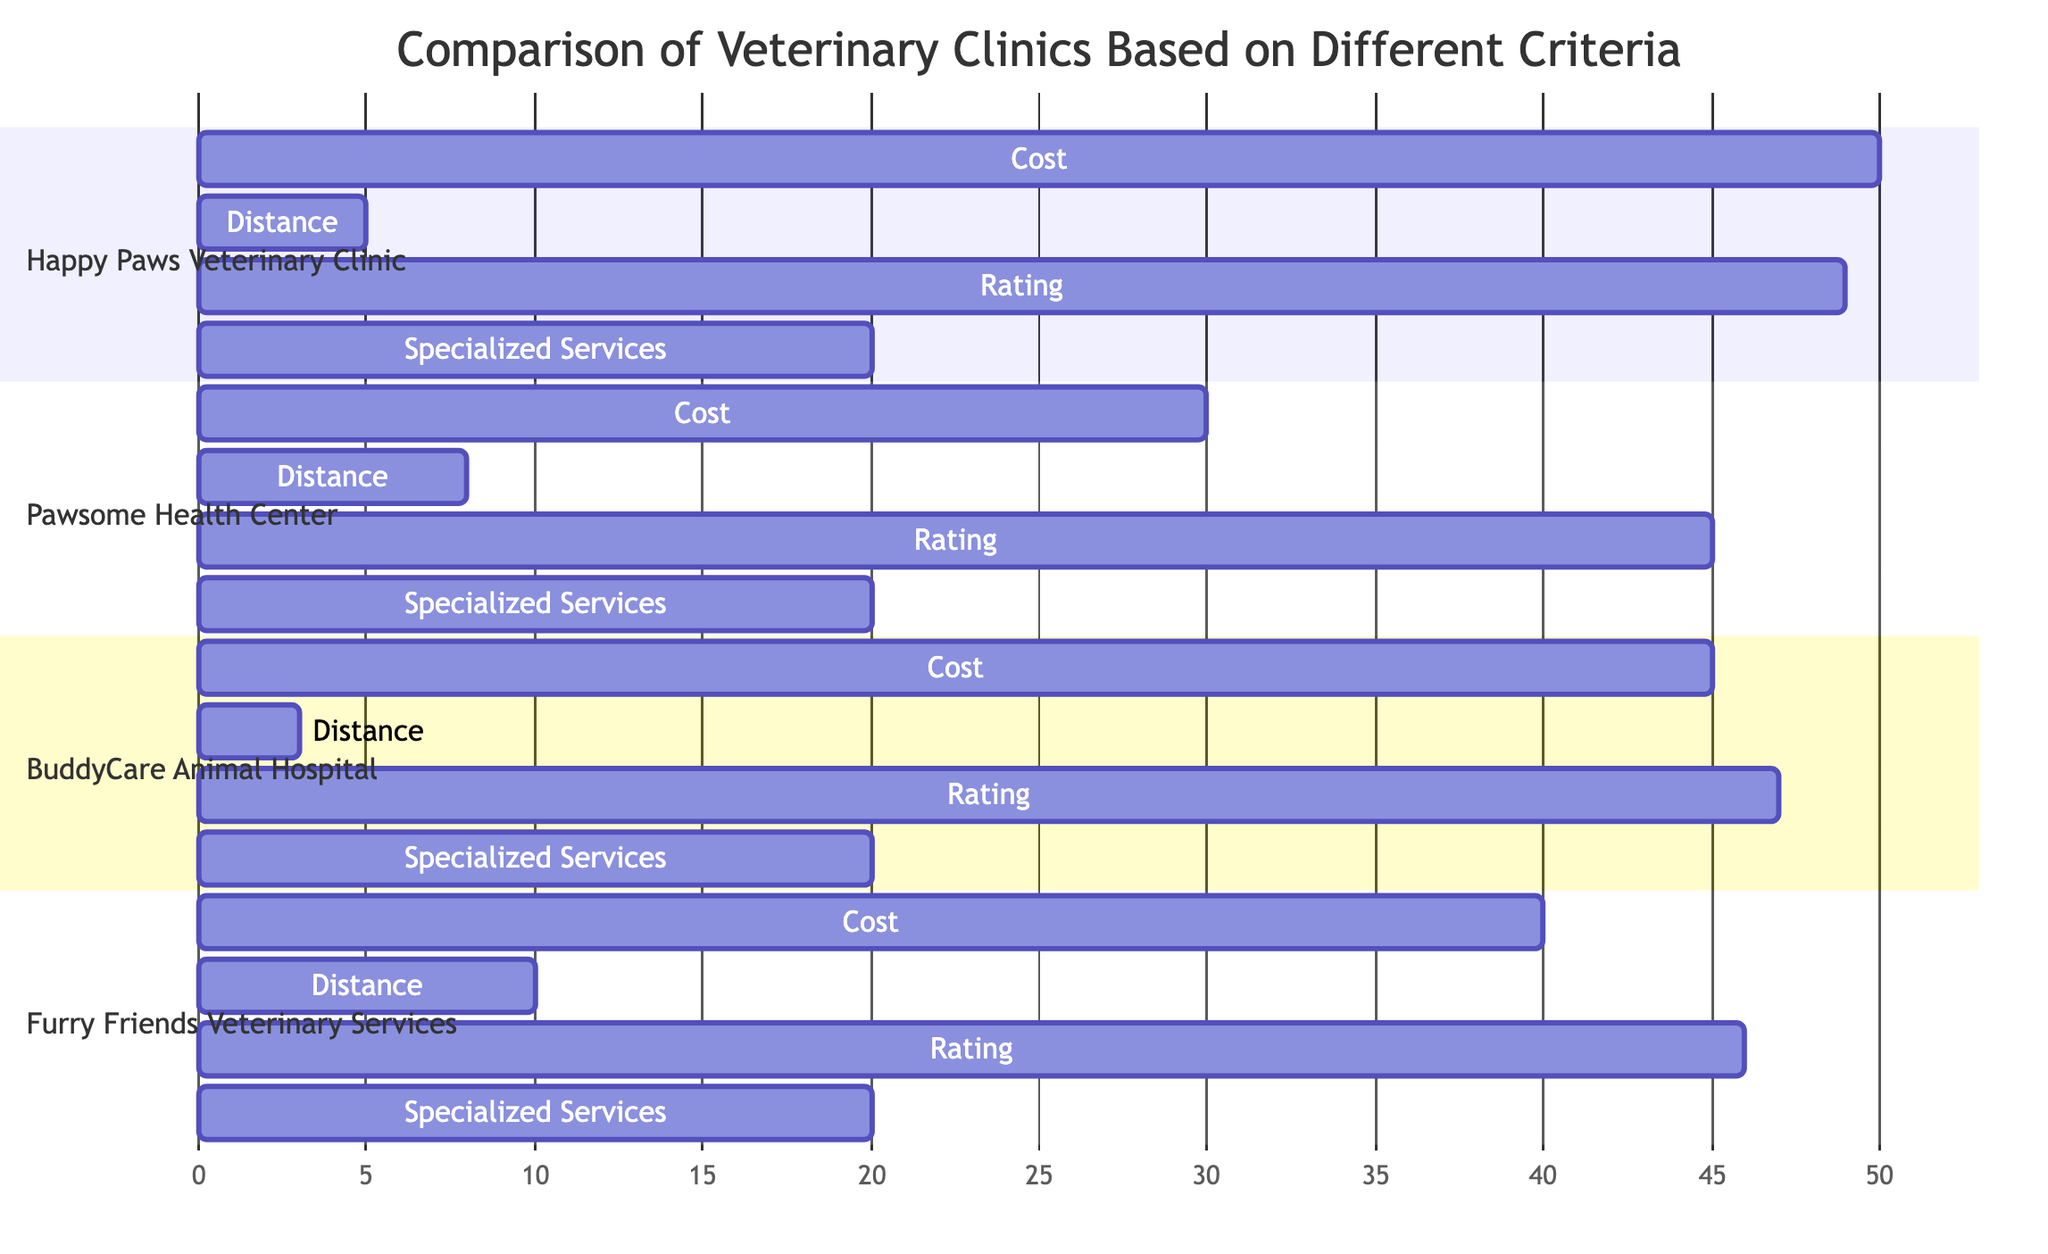What is the cost of Happy Paws Veterinary Clinic? The cost for Happy Paws Veterinary Clinic is clearly indicated as 50 in the diagram.
Answer: 50 What is the distance to Pawsome Health Center? The distance to Pawsome Health Center is shown as 8 in the diagram.
Answer: 8 Which clinic has the highest rating? By comparing the ratings of all clinics, Happy Paws Veterinary Clinic has the highest rating of 49.
Answer: Happy Paws Veterinary Clinic What is the specialized services score for Furry Friends Veterinary Services? The specialized services score for Furry Friends Veterinary Services is indicated as 20 in the diagram.
Answer: 20 How does the cost of BuddyCare Animal Hospital compare to Pawsome Health Center? BuddyCare Animal Hospital has a cost of 45, while Pawsome Health Center has a cost of 30. Thus, BuddyCare's cost is higher by 15.
Answer: Higher by 15 Which clinic offers the lowest cost overall? Upon examining the cost values, Pawsome Health Center has the lowest cost at 30 among all clinics.
Answer: Pawsome Health Center What is the distance difference between Furry Friends Veterinary Services and BuddyCare Animal Hospital? Furry Friends Veterinary Services has a distance of 10, while BuddyCare Animal Hospital has a distance of 3. The difference is calculated as 10 - 3 = 7.
Answer: 7 What is the average rating of all clinics combined? The ratings of the clinics are 49, 45, 47, and 46. Adding these gives 187, and dividing by 4 (the number of clinics) gives an average of 46.75. The average rating can be rounded to 47 for simplification.
Answer: 47 